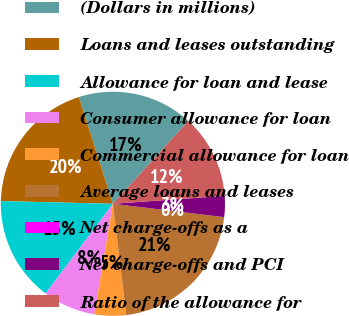<chart> <loc_0><loc_0><loc_500><loc_500><pie_chart><fcel>(Dollars in millions)<fcel>Loans and leases outstanding<fcel>Allowance for loan and lease<fcel>Consumer allowance for loan<fcel>Commercial allowance for loan<fcel>Average loans and leases<fcel>Net charge-offs as a<fcel>Net charge-offs and PCI<fcel>Ratio of the allowance for<nl><fcel>16.67%<fcel>19.7%<fcel>15.15%<fcel>7.58%<fcel>4.55%<fcel>21.21%<fcel>0.0%<fcel>3.03%<fcel>12.12%<nl></chart> 